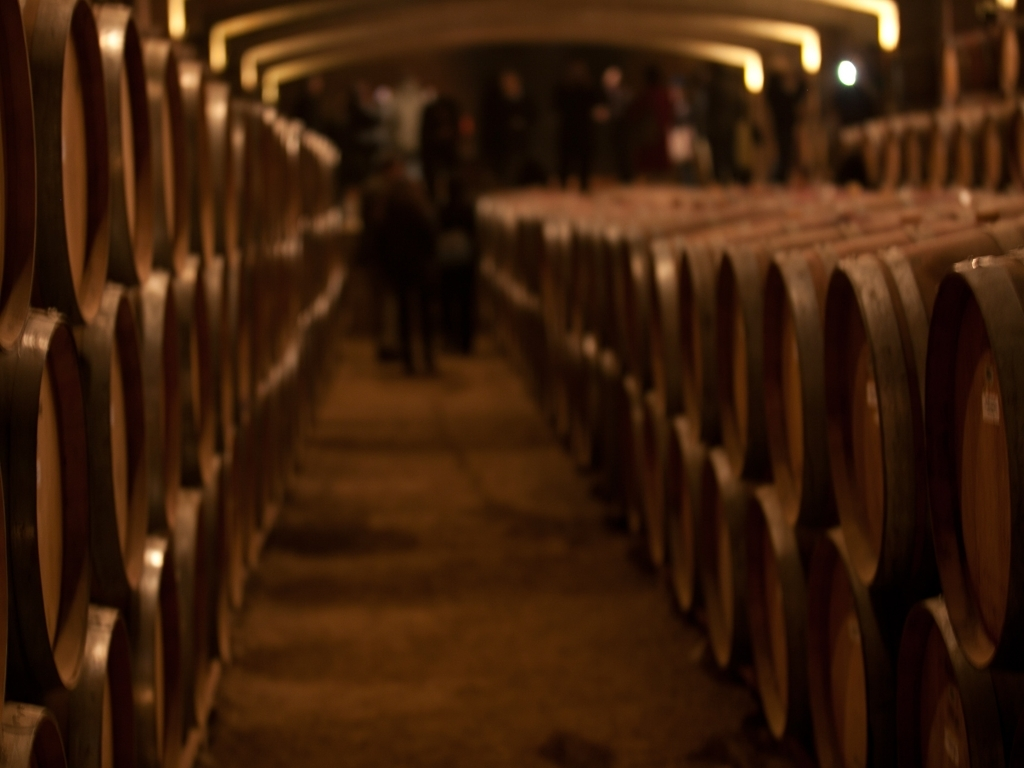This image seems to capture movement; what does this imply about the atmosphere in this location? The presence of motion blur, especially around the figure in the background, imparts a sense of activity and possibly the daily work that takes place in this storage area. It gives viewers a glimpse into the bustling yet unseen life within a wine or spirit aging cellar. 